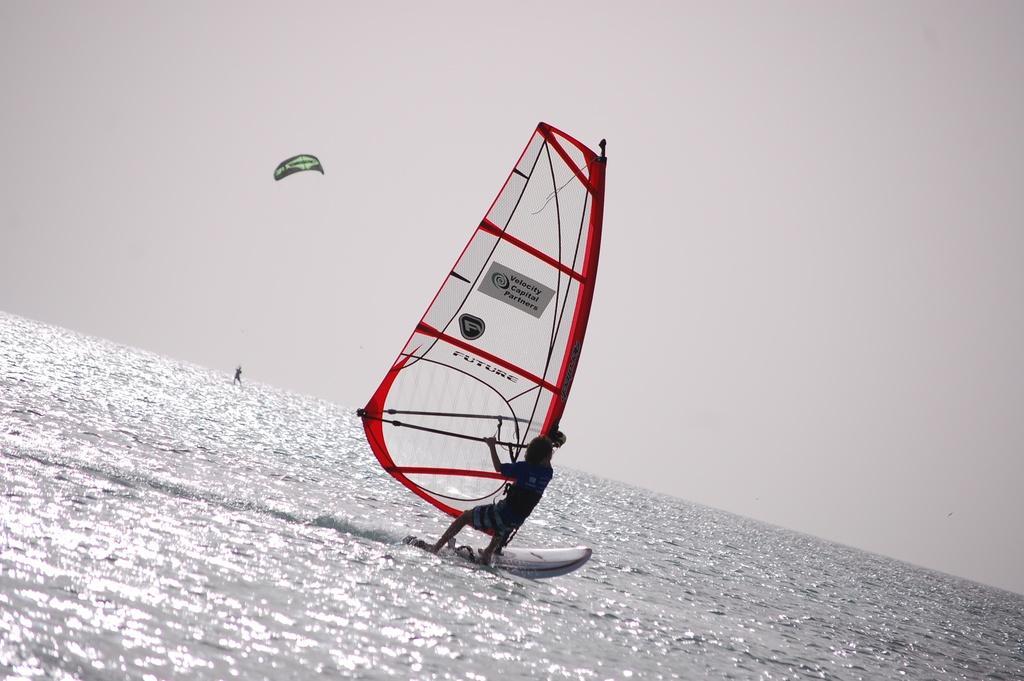In one or two sentences, can you explain what this image depicts? In this image, we can see a person surfing on the water and in the background, we can see a parasailing. At the top, there is sky. 